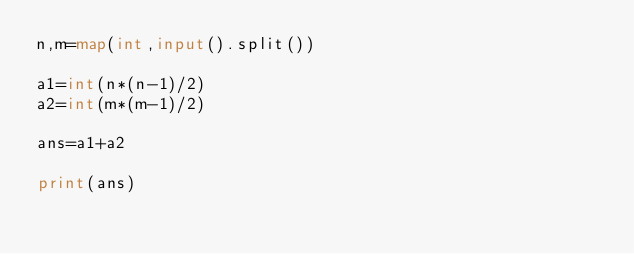Convert code to text. <code><loc_0><loc_0><loc_500><loc_500><_Python_>n,m=map(int,input().split())

a1=int(n*(n-1)/2)
a2=int(m*(m-1)/2)

ans=a1+a2

print(ans)</code> 